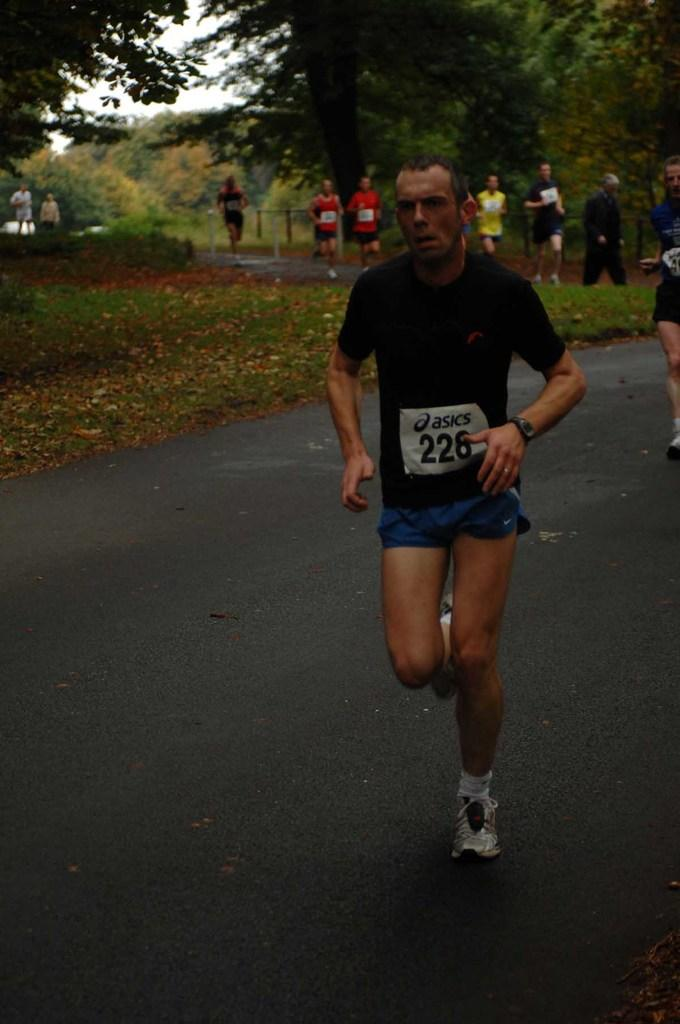What are the people in the image doing? The people in the image are running on the road. What type of vegetation can be seen in the image? There are trees, plants, leaves, and grass in the image. What part of the natural environment is visible in the image? The sky is visible in the image. Can you tell me how many goldfish are swimming in the image? There are no goldfish present in the image. What type of store can be seen in the image? There is no store visible in the image. 